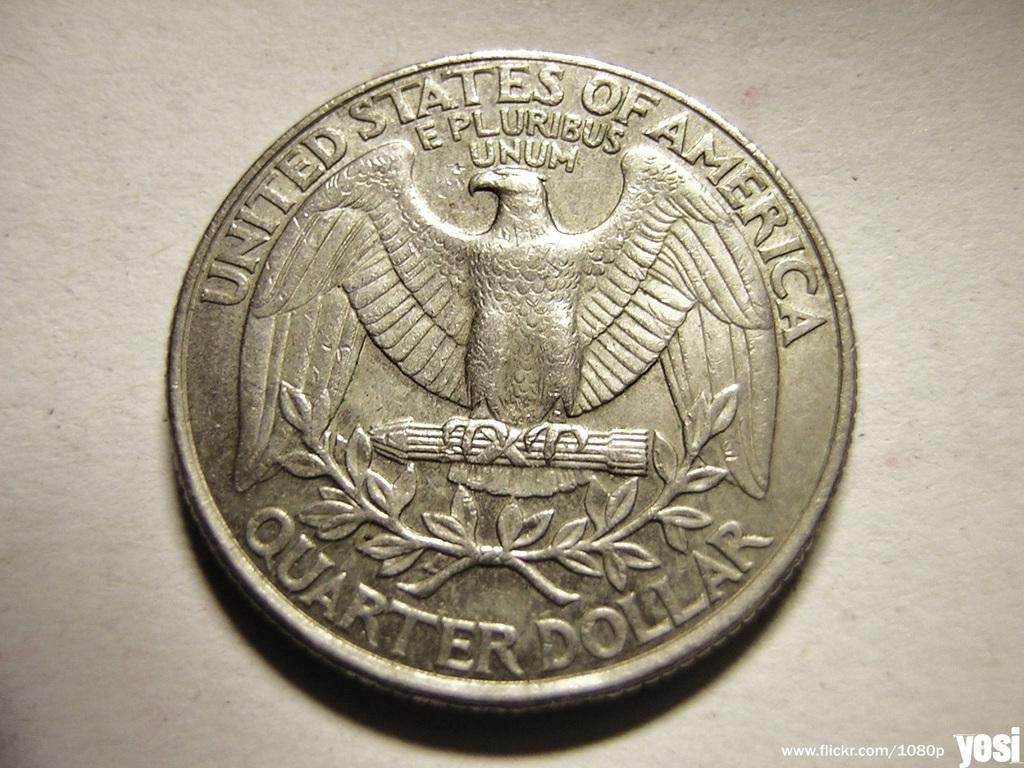<image>
Offer a succinct explanation of the picture presented. A quarter dollar coin from the United States of America. 